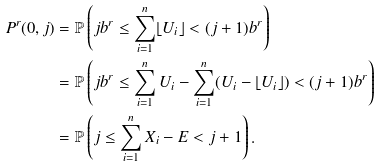<formula> <loc_0><loc_0><loc_500><loc_500>P ^ { r } ( 0 , j ) & = \mathbb { P } \left ( j b ^ { r } \leq \sum _ { i = 1 } ^ { n } \lfloor U _ { i } \rfloor < ( j + 1 ) b ^ { r } \right ) \\ & = \mathbb { P } \left ( j b ^ { r } \leq \sum _ { i = 1 } ^ { n } U _ { i } - \sum _ { i = 1 } ^ { n } ( U _ { i } - \lfloor U _ { i } \rfloor ) < ( j + 1 ) b ^ { r } \right ) \\ & = \mathbb { P } \left ( j \leq \sum _ { i = 1 } ^ { n } X _ { i } - E < j + 1 \right ) .</formula> 